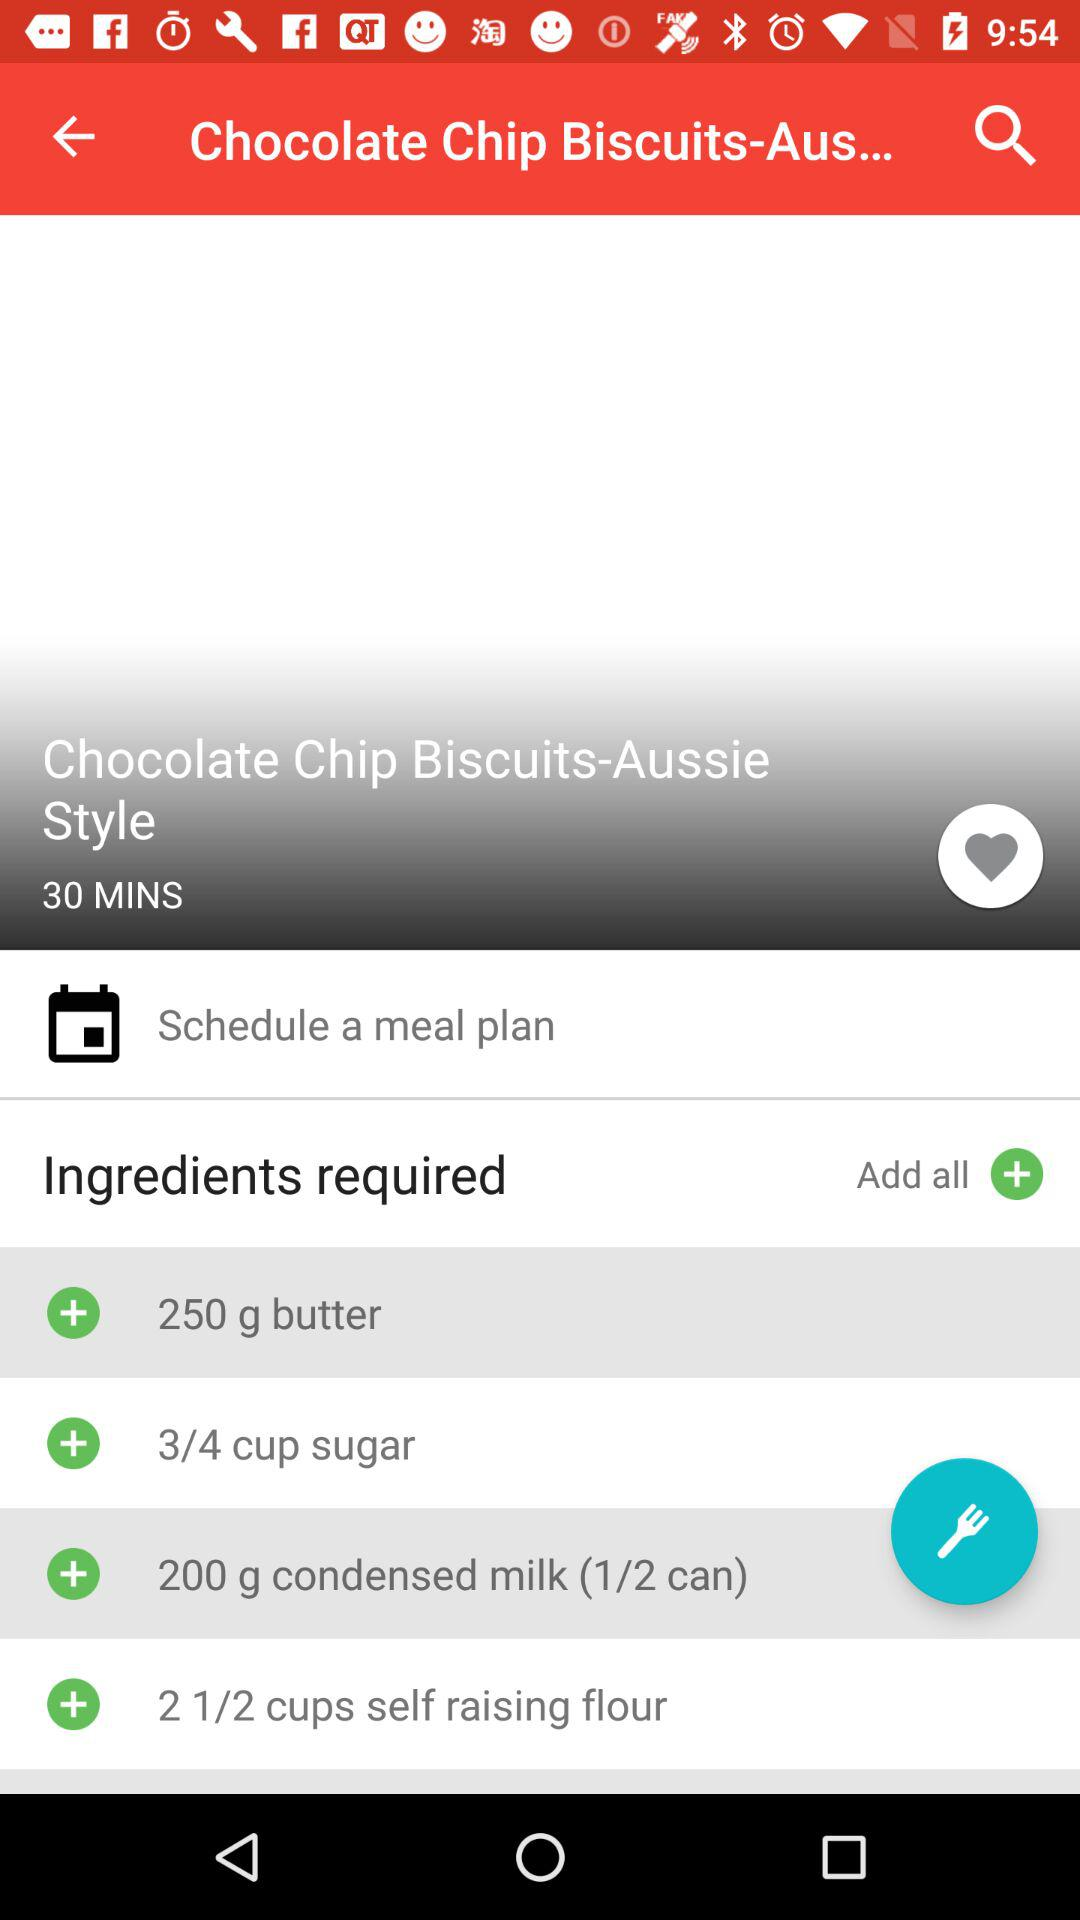How many cups of sugar are required? There is 3/4 cup of sugar required. 